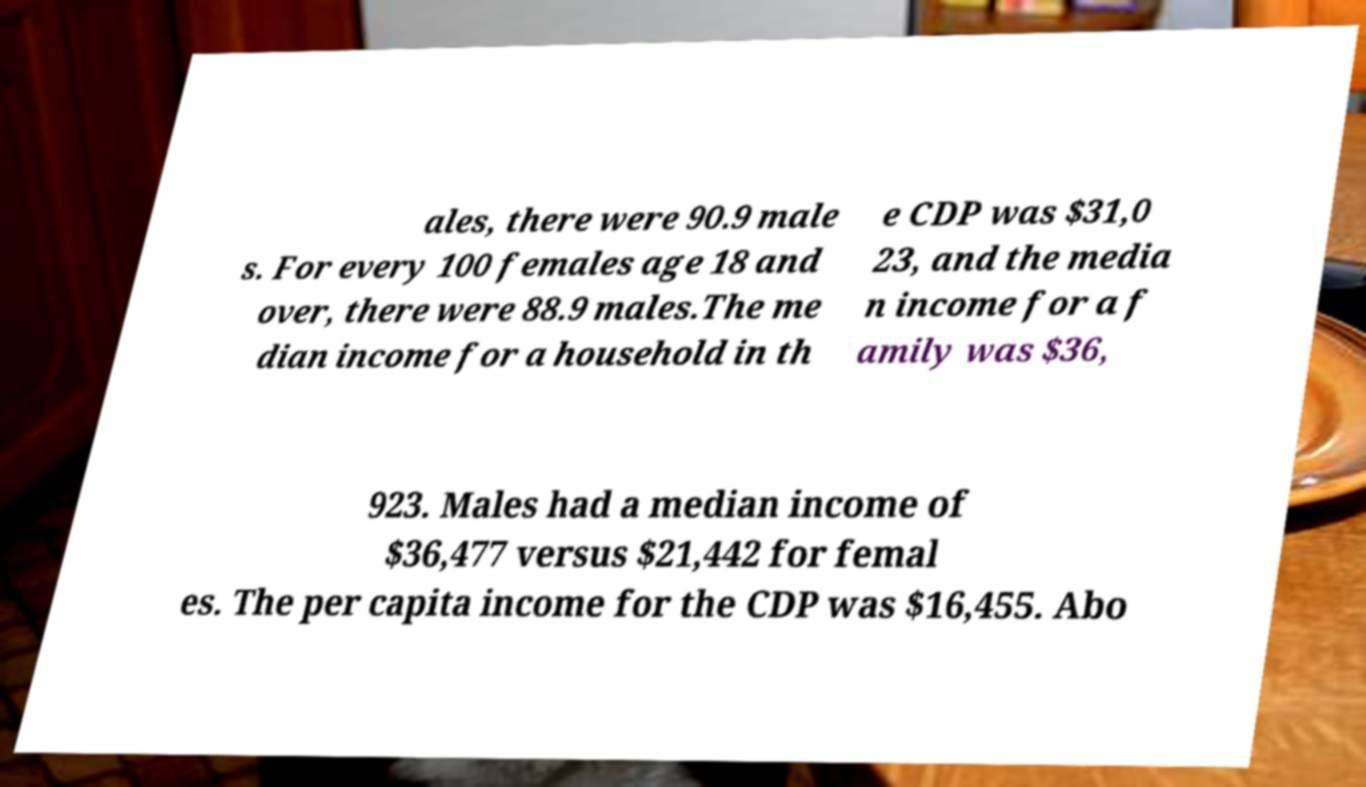For documentation purposes, I need the text within this image transcribed. Could you provide that? ales, there were 90.9 male s. For every 100 females age 18 and over, there were 88.9 males.The me dian income for a household in th e CDP was $31,0 23, and the media n income for a f amily was $36, 923. Males had a median income of $36,477 versus $21,442 for femal es. The per capita income for the CDP was $16,455. Abo 